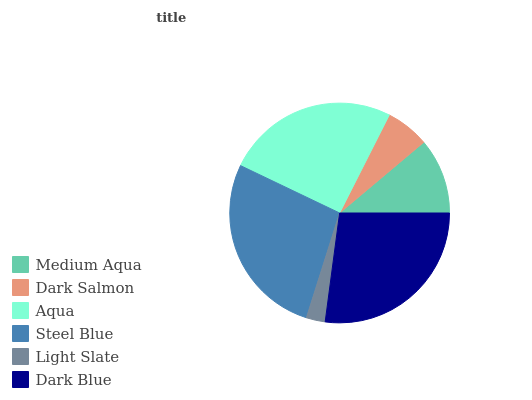Is Light Slate the minimum?
Answer yes or no. Yes. Is Steel Blue the maximum?
Answer yes or no. Yes. Is Dark Salmon the minimum?
Answer yes or no. No. Is Dark Salmon the maximum?
Answer yes or no. No. Is Medium Aqua greater than Dark Salmon?
Answer yes or no. Yes. Is Dark Salmon less than Medium Aqua?
Answer yes or no. Yes. Is Dark Salmon greater than Medium Aqua?
Answer yes or no. No. Is Medium Aqua less than Dark Salmon?
Answer yes or no. No. Is Aqua the high median?
Answer yes or no. Yes. Is Medium Aqua the low median?
Answer yes or no. Yes. Is Medium Aqua the high median?
Answer yes or no. No. Is Light Slate the low median?
Answer yes or no. No. 